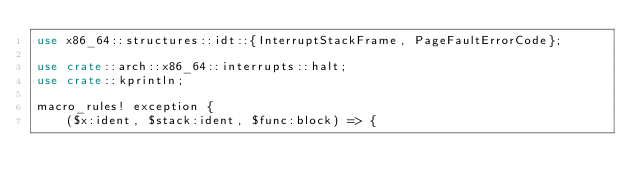Convert code to text. <code><loc_0><loc_0><loc_500><loc_500><_Rust_>use x86_64::structures::idt::{InterruptStackFrame, PageFaultErrorCode};

use crate::arch::x86_64::interrupts::halt;
use crate::kprintln;

macro_rules! exception {
    ($x:ident, $stack:ident, $func:block) => {</code> 